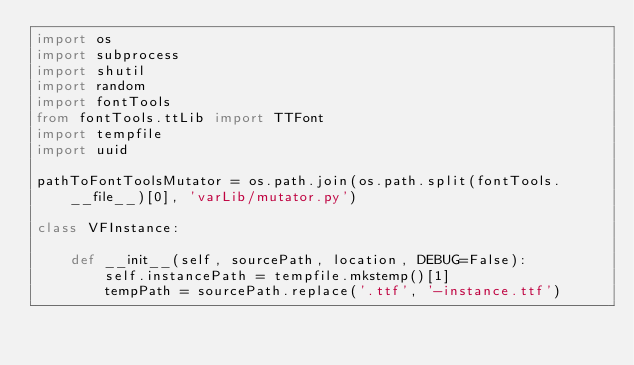<code> <loc_0><loc_0><loc_500><loc_500><_Python_>import os
import subprocess
import shutil
import random
import fontTools
from fontTools.ttLib import TTFont
import tempfile
import uuid

pathToFontToolsMutator = os.path.join(os.path.split(fontTools.__file__)[0], 'varLib/mutator.py')

class VFInstance:
    
    def __init__(self, sourcePath, location, DEBUG=False):
        self.instancePath = tempfile.mkstemp()[1]
        tempPath = sourcePath.replace('.ttf', '-instance.ttf')
        </code> 